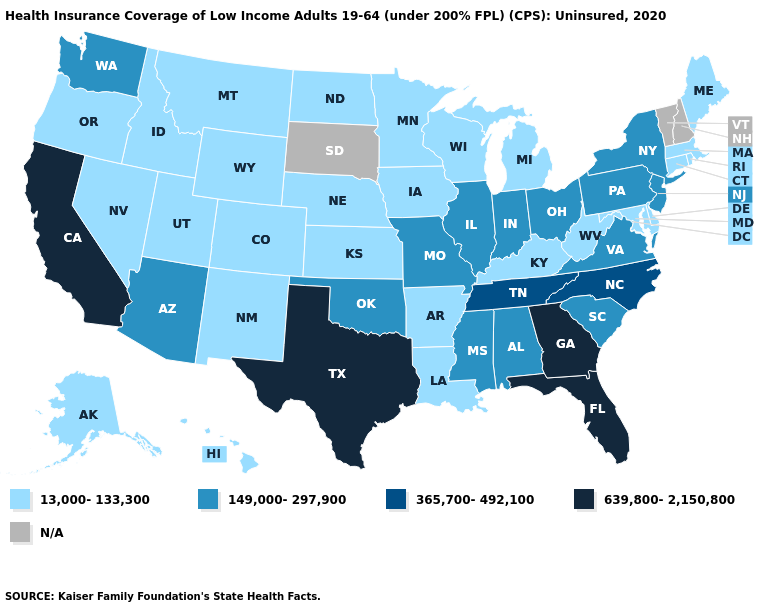Which states hav the highest value in the West?
Keep it brief. California. Name the states that have a value in the range 13,000-133,300?
Keep it brief. Alaska, Arkansas, Colorado, Connecticut, Delaware, Hawaii, Idaho, Iowa, Kansas, Kentucky, Louisiana, Maine, Maryland, Massachusetts, Michigan, Minnesota, Montana, Nebraska, Nevada, New Mexico, North Dakota, Oregon, Rhode Island, Utah, West Virginia, Wisconsin, Wyoming. What is the lowest value in the USA?
Answer briefly. 13,000-133,300. Does Minnesota have the highest value in the MidWest?
Short answer required. No. Does the map have missing data?
Be succinct. Yes. Does New York have the highest value in the Northeast?
Quick response, please. Yes. Name the states that have a value in the range 639,800-2,150,800?
Write a very short answer. California, Florida, Georgia, Texas. Which states hav the highest value in the MidWest?
Write a very short answer. Illinois, Indiana, Missouri, Ohio. Which states have the lowest value in the Northeast?
Answer briefly. Connecticut, Maine, Massachusetts, Rhode Island. Name the states that have a value in the range 639,800-2,150,800?
Short answer required. California, Florida, Georgia, Texas. Name the states that have a value in the range 639,800-2,150,800?
Keep it brief. California, Florida, Georgia, Texas. What is the value of Utah?
Answer briefly. 13,000-133,300. Does Iowa have the lowest value in the USA?
Answer briefly. Yes. 